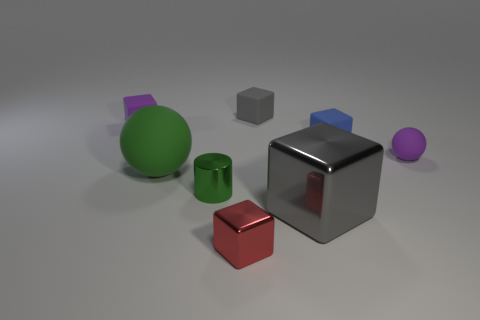Is the color of the big shiny thing the same as the shiny cylinder?
Provide a succinct answer. No. The cube that is in front of the blue matte block and on the left side of the large gray metallic cube is made of what material?
Offer a very short reply. Metal. There is a large gray shiny cube; how many small balls are right of it?
Provide a short and direct response. 1. There is a tiny gray thing; is its shape the same as the small purple object that is behind the purple ball?
Offer a terse response. Yes. Is there another matte thing of the same shape as the big green thing?
Provide a short and direct response. Yes. There is a purple thing to the left of the matte object that is behind the small purple rubber cube; what shape is it?
Provide a short and direct response. Cube. There is a tiny metal thing in front of the cylinder; what shape is it?
Your answer should be very brief. Cube. There is a ball that is left of the green cylinder; is it the same color as the large object that is in front of the cylinder?
Make the answer very short. No. What number of cubes are both on the left side of the big gray cube and in front of the large rubber thing?
Make the answer very short. 1. There is a gray cube that is the same material as the green cylinder; what is its size?
Your response must be concise. Large. 